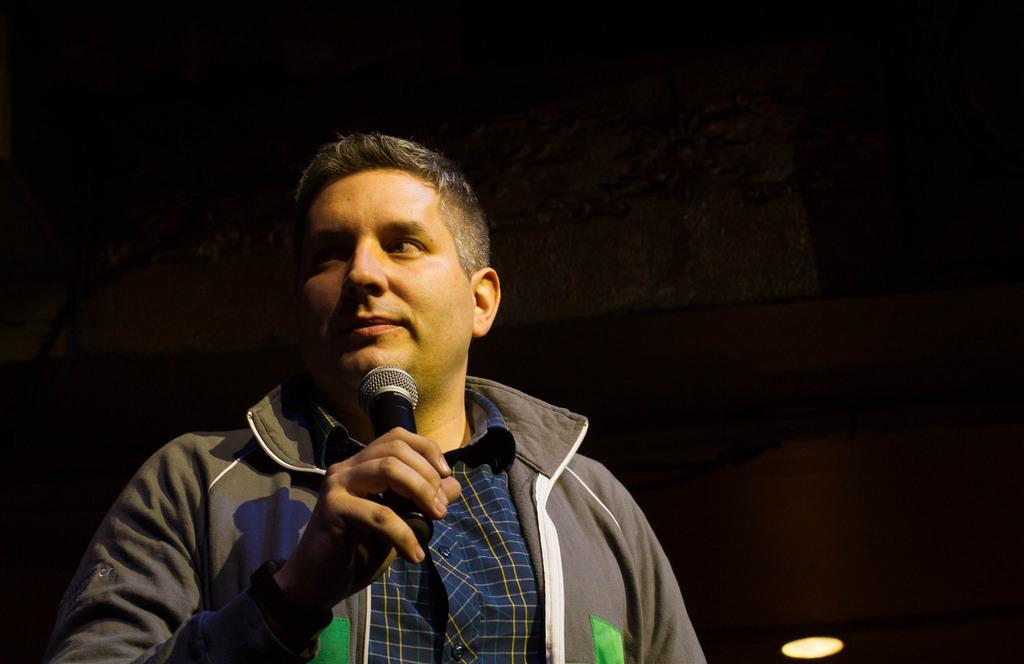Can you describe this image briefly? In the foreground a person is standing and holding a mike in his hand. The background is dark in color. At the bottom light is visible. This image is taken during night time. 